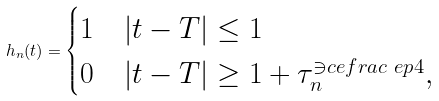Convert formula to latex. <formula><loc_0><loc_0><loc_500><loc_500>h _ { n } ( t ) = \begin{cases} 1 & | t - T | \leq 1 \\ 0 & | t - T | \geq 1 + \tau _ { n } ^ { \ni c e f r a c { \ e p } { 4 } } , \end{cases}</formula> 